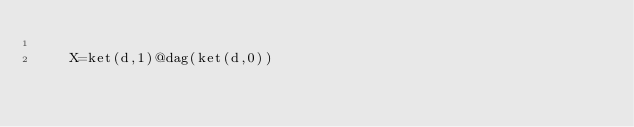Convert code to text. <code><loc_0><loc_0><loc_500><loc_500><_Python_>
    X=ket(d,1)@dag(ket(d,0))
</code> 